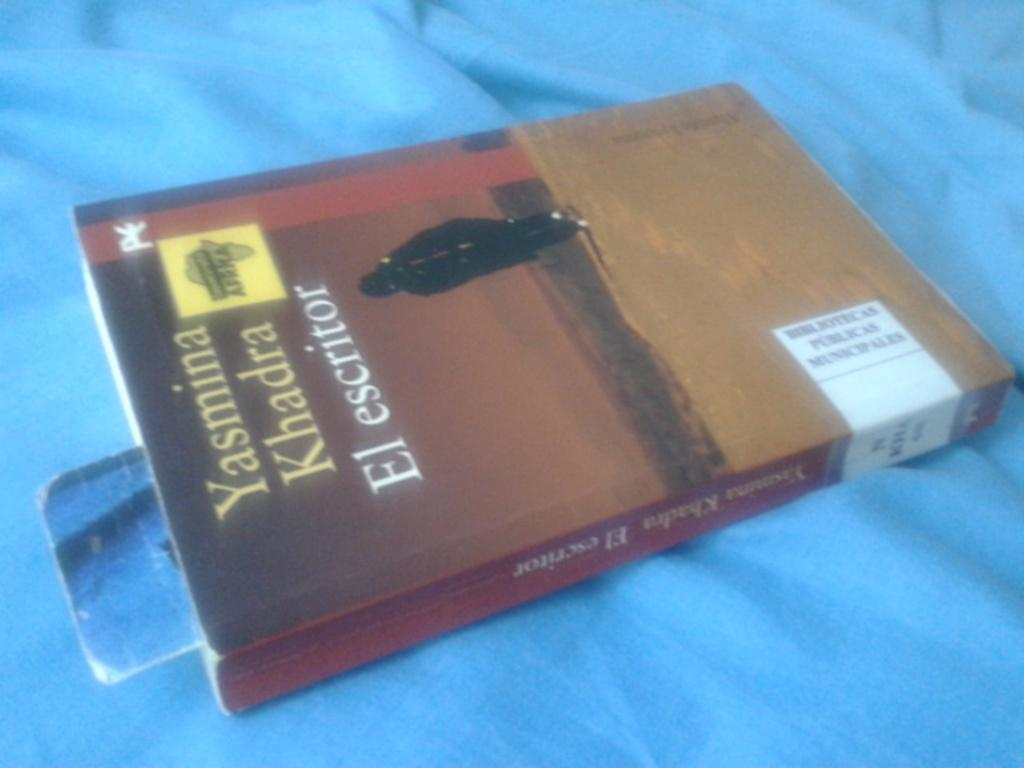Provide a one-sentence caption for the provided image. A book called Yasmina Khadra El escritor is on a blue blanket. 